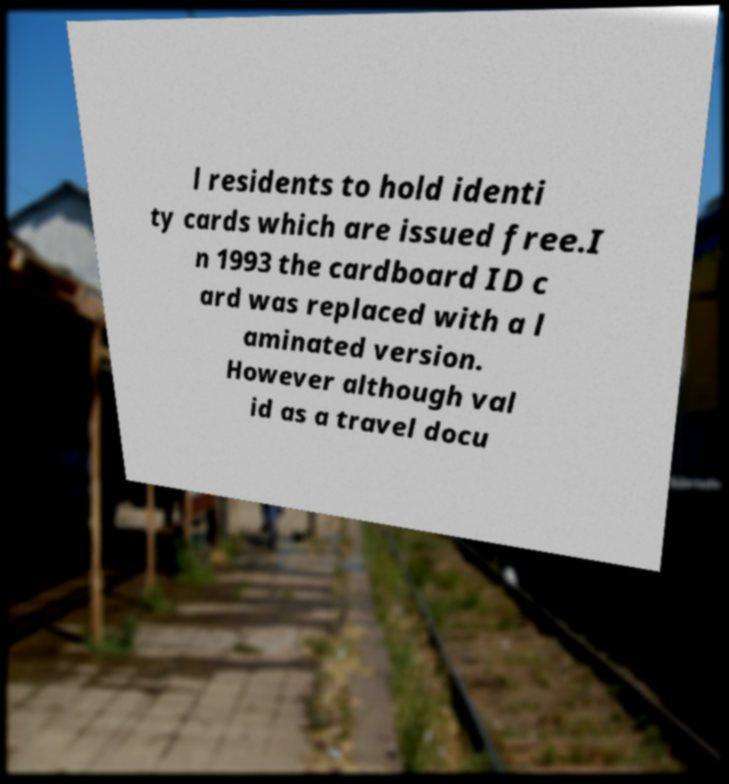Please identify and transcribe the text found in this image. l residents to hold identi ty cards which are issued free.I n 1993 the cardboard ID c ard was replaced with a l aminated version. However although val id as a travel docu 